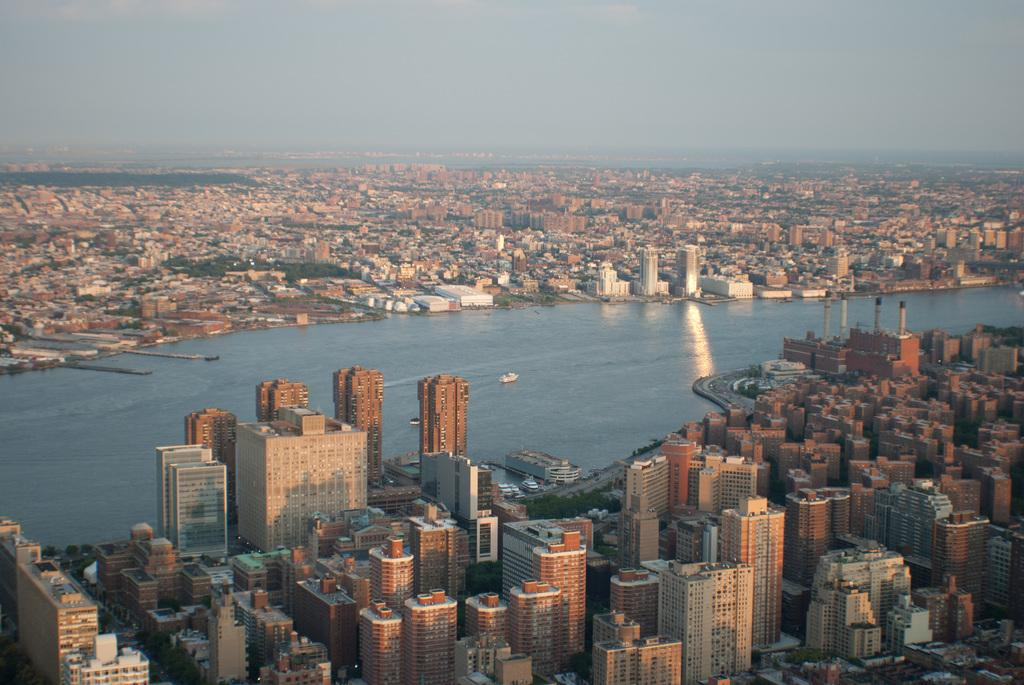What is visible in the image? Water, buildings, and the sky are visible in the image. Can you describe the water in the image? The water is visible, but its specific characteristics are not mentioned in the facts. What can be seen in the background of the image? The sky is visible in the background of the image. Where is the grandmother located in the image? There is no mention of a grandmother in the image or the provided facts. What type of airport can be seen in the image? There is no mention of an airport in the image or the provided facts. 